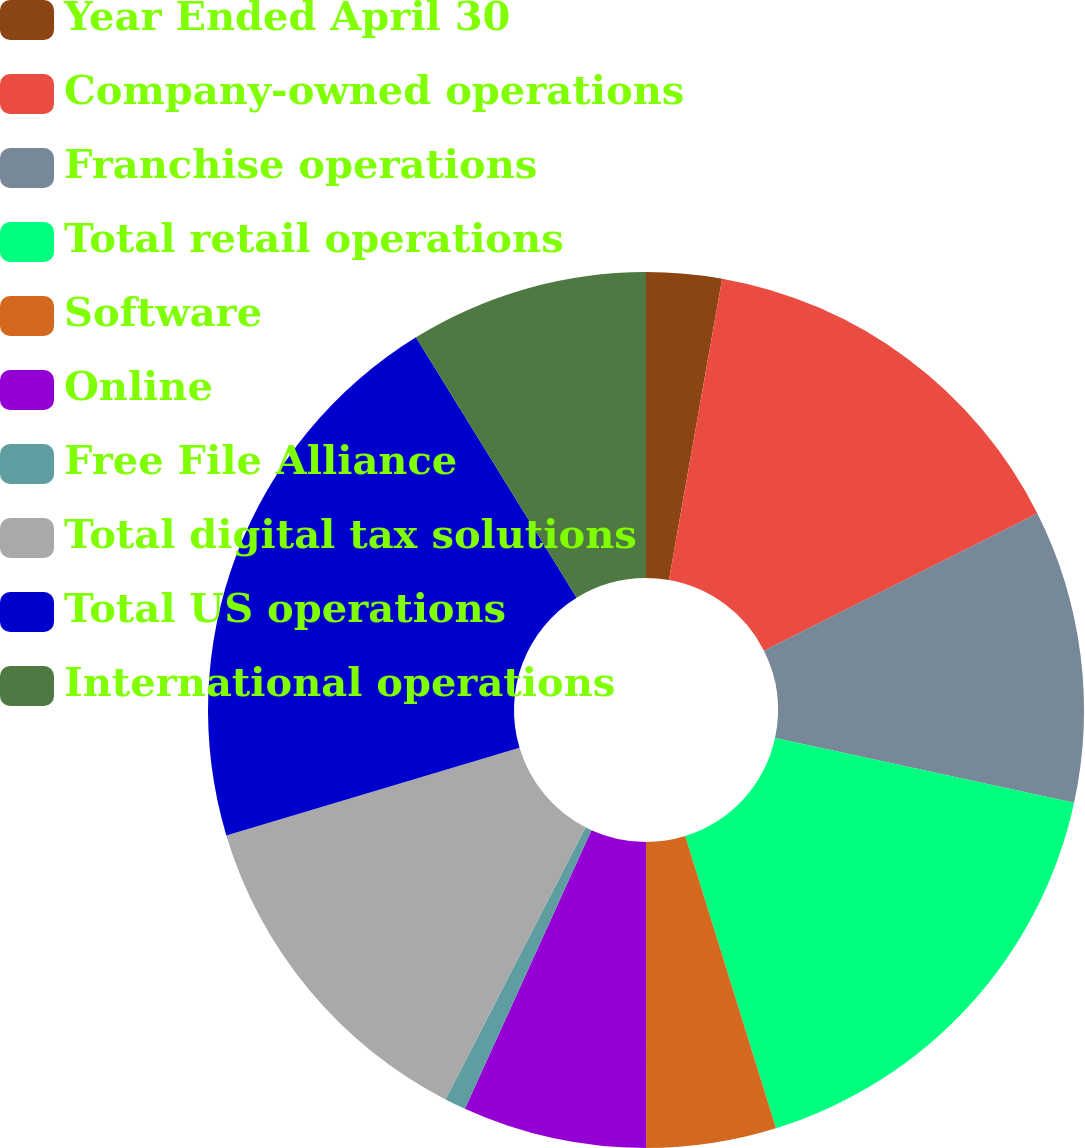Convert chart. <chart><loc_0><loc_0><loc_500><loc_500><pie_chart><fcel>Year Ended April 30<fcel>Company-owned operations<fcel>Franchise operations<fcel>Total retail operations<fcel>Software<fcel>Online<fcel>Free File Alliance<fcel>Total digital tax solutions<fcel>Total US operations<fcel>International operations<nl><fcel>2.78%<fcel>14.81%<fcel>10.8%<fcel>16.81%<fcel>4.79%<fcel>6.79%<fcel>0.78%<fcel>12.81%<fcel>20.82%<fcel>8.8%<nl></chart> 